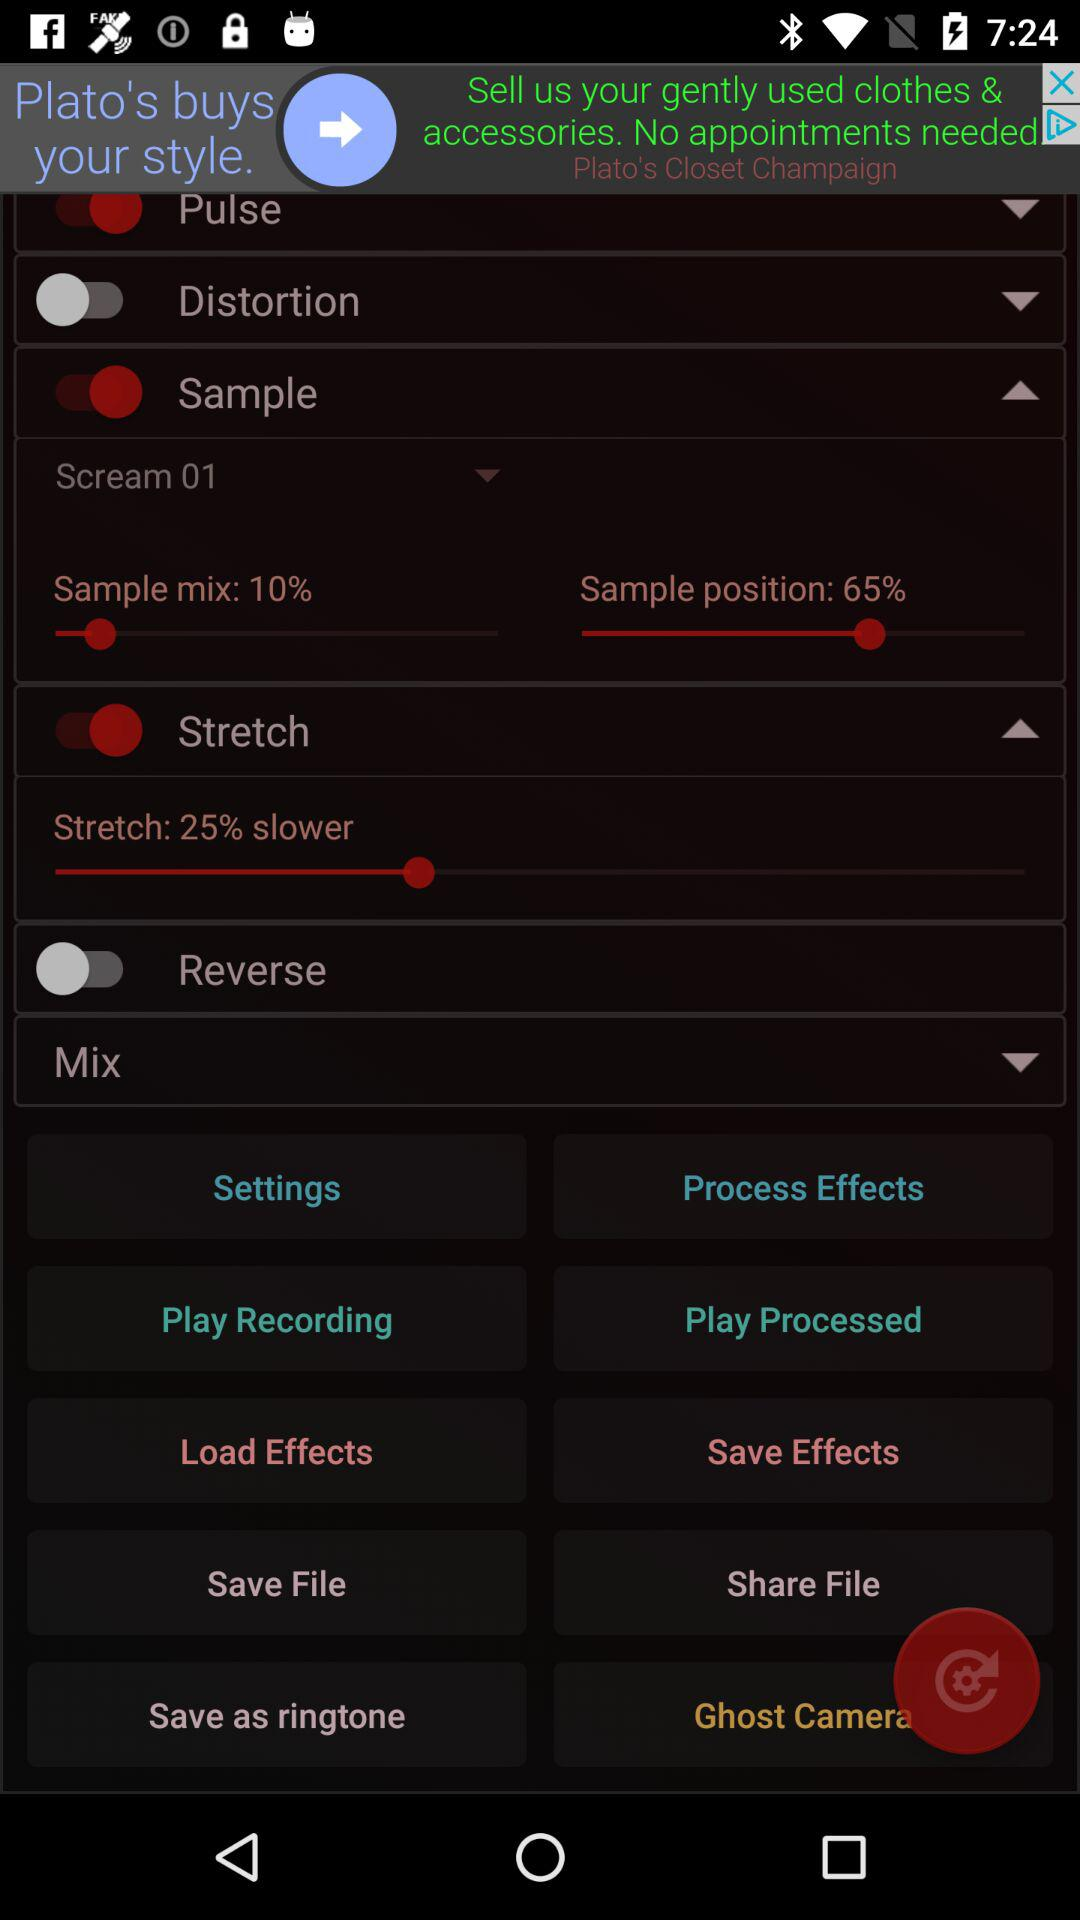What is the selected sample mix? The sample mix is 10%. 